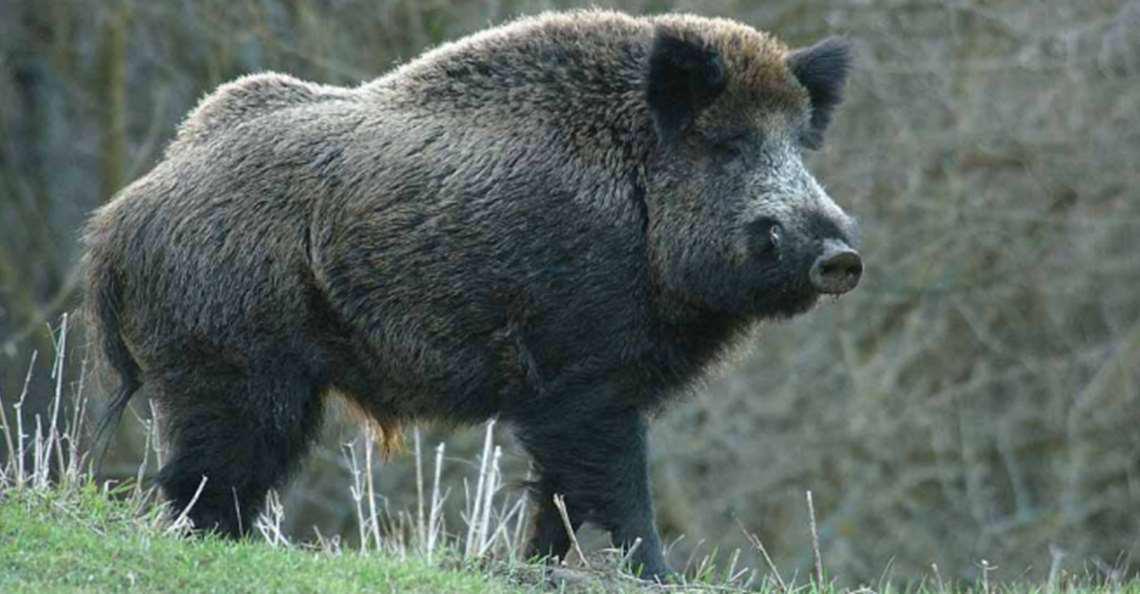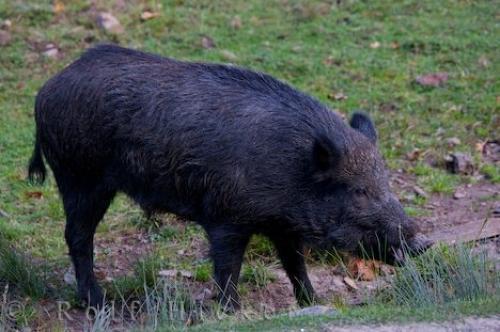The first image is the image on the left, the second image is the image on the right. Assess this claim about the two images: "The animal in the image on the right is facing right.". Correct or not? Answer yes or no. Yes. 